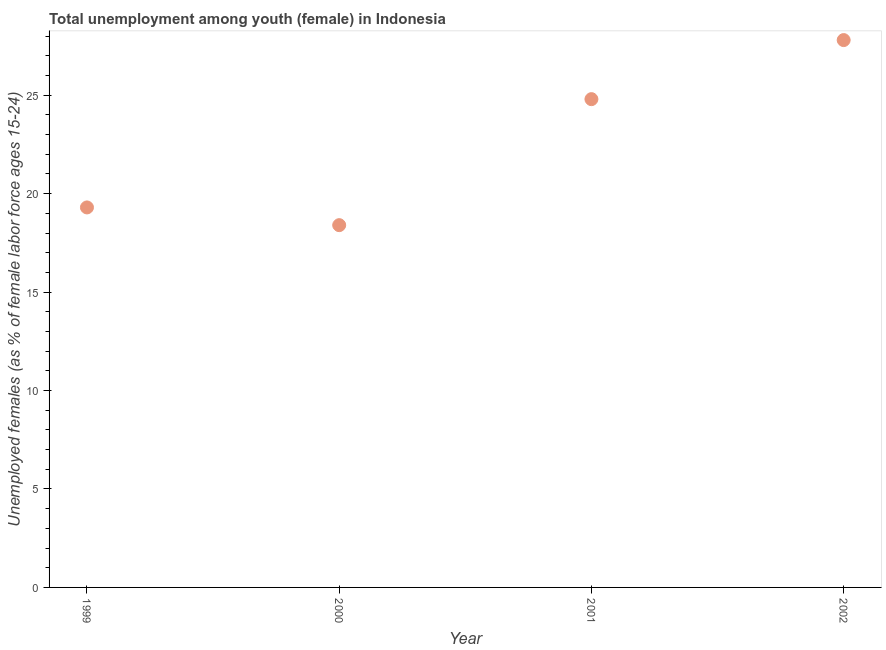What is the unemployed female youth population in 2002?
Your response must be concise. 27.8. Across all years, what is the maximum unemployed female youth population?
Offer a very short reply. 27.8. Across all years, what is the minimum unemployed female youth population?
Give a very brief answer. 18.4. In which year was the unemployed female youth population minimum?
Your answer should be compact. 2000. What is the sum of the unemployed female youth population?
Keep it short and to the point. 90.3. What is the difference between the unemployed female youth population in 2000 and 2001?
Keep it short and to the point. -6.4. What is the average unemployed female youth population per year?
Make the answer very short. 22.57. What is the median unemployed female youth population?
Offer a very short reply. 22.05. In how many years, is the unemployed female youth population greater than 27 %?
Your answer should be compact. 1. Do a majority of the years between 2001 and 1999 (inclusive) have unemployed female youth population greater than 19 %?
Provide a succinct answer. No. What is the ratio of the unemployed female youth population in 2000 to that in 2001?
Ensure brevity in your answer.  0.74. Is the unemployed female youth population in 1999 less than that in 2002?
Provide a succinct answer. Yes. Is the difference between the unemployed female youth population in 1999 and 2002 greater than the difference between any two years?
Offer a terse response. No. What is the difference between the highest and the second highest unemployed female youth population?
Offer a terse response. 3. Is the sum of the unemployed female youth population in 2000 and 2002 greater than the maximum unemployed female youth population across all years?
Your response must be concise. Yes. What is the difference between the highest and the lowest unemployed female youth population?
Provide a succinct answer. 9.4. How many years are there in the graph?
Keep it short and to the point. 4. Are the values on the major ticks of Y-axis written in scientific E-notation?
Your answer should be compact. No. Does the graph contain any zero values?
Give a very brief answer. No. Does the graph contain grids?
Offer a terse response. No. What is the title of the graph?
Provide a short and direct response. Total unemployment among youth (female) in Indonesia. What is the label or title of the X-axis?
Make the answer very short. Year. What is the label or title of the Y-axis?
Keep it short and to the point. Unemployed females (as % of female labor force ages 15-24). What is the Unemployed females (as % of female labor force ages 15-24) in 1999?
Your response must be concise. 19.3. What is the Unemployed females (as % of female labor force ages 15-24) in 2000?
Make the answer very short. 18.4. What is the Unemployed females (as % of female labor force ages 15-24) in 2001?
Offer a very short reply. 24.8. What is the Unemployed females (as % of female labor force ages 15-24) in 2002?
Provide a short and direct response. 27.8. What is the difference between the Unemployed females (as % of female labor force ages 15-24) in 1999 and 2000?
Your response must be concise. 0.9. What is the difference between the Unemployed females (as % of female labor force ages 15-24) in 1999 and 2001?
Give a very brief answer. -5.5. What is the difference between the Unemployed females (as % of female labor force ages 15-24) in 1999 and 2002?
Your answer should be very brief. -8.5. What is the difference between the Unemployed females (as % of female labor force ages 15-24) in 2000 and 2002?
Your answer should be compact. -9.4. What is the ratio of the Unemployed females (as % of female labor force ages 15-24) in 1999 to that in 2000?
Provide a succinct answer. 1.05. What is the ratio of the Unemployed females (as % of female labor force ages 15-24) in 1999 to that in 2001?
Offer a very short reply. 0.78. What is the ratio of the Unemployed females (as % of female labor force ages 15-24) in 1999 to that in 2002?
Provide a short and direct response. 0.69. What is the ratio of the Unemployed females (as % of female labor force ages 15-24) in 2000 to that in 2001?
Your answer should be compact. 0.74. What is the ratio of the Unemployed females (as % of female labor force ages 15-24) in 2000 to that in 2002?
Your response must be concise. 0.66. What is the ratio of the Unemployed females (as % of female labor force ages 15-24) in 2001 to that in 2002?
Ensure brevity in your answer.  0.89. 